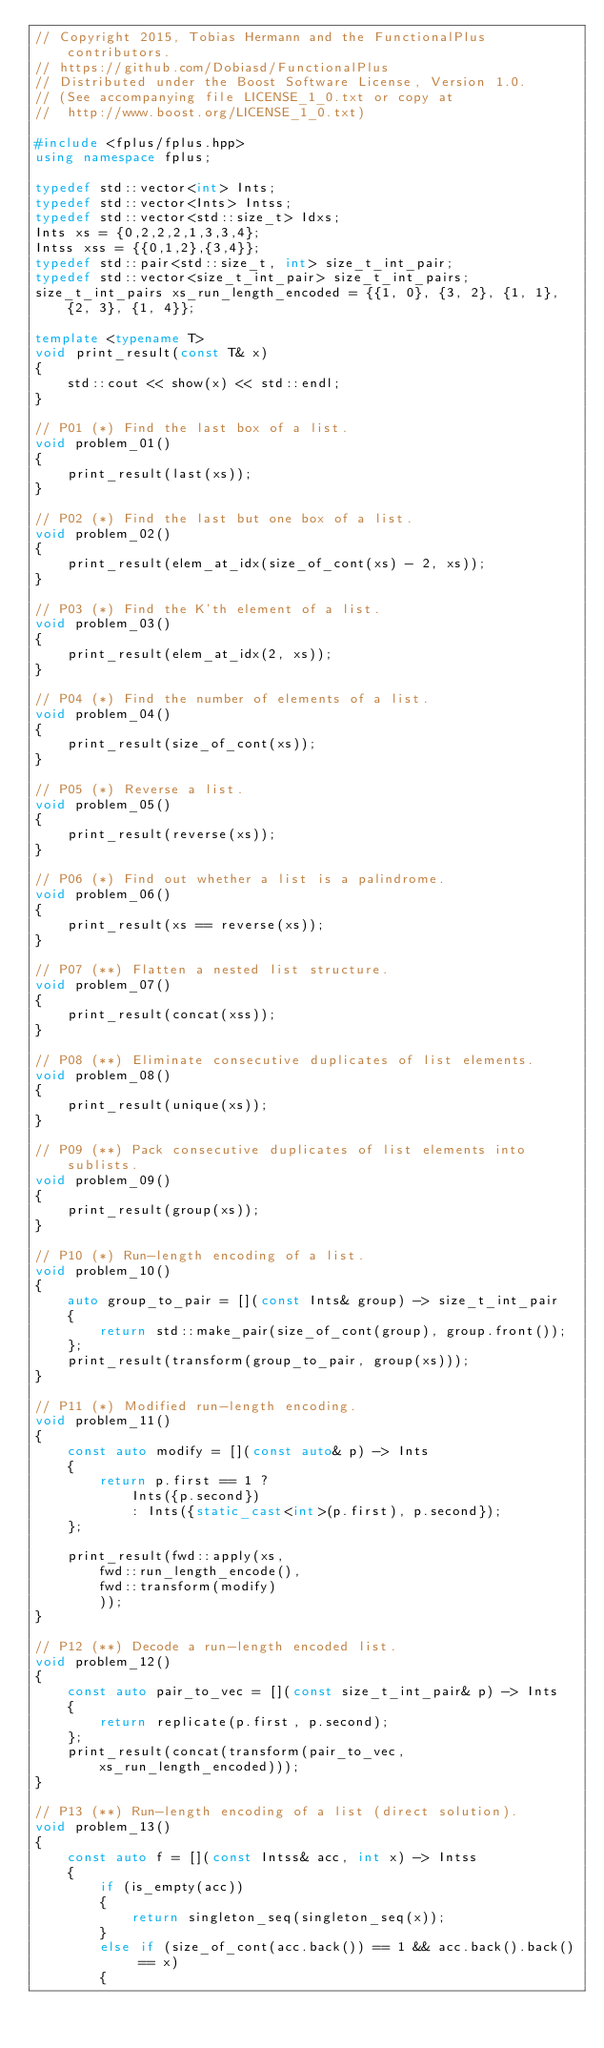<code> <loc_0><loc_0><loc_500><loc_500><_C++_>// Copyright 2015, Tobias Hermann and the FunctionalPlus contributors.
// https://github.com/Dobiasd/FunctionalPlus
// Distributed under the Boost Software License, Version 1.0.
// (See accompanying file LICENSE_1_0.txt or copy at
//  http://www.boost.org/LICENSE_1_0.txt)

#include <fplus/fplus.hpp>
using namespace fplus;

typedef std::vector<int> Ints;
typedef std::vector<Ints> Intss;
typedef std::vector<std::size_t> Idxs;
Ints xs = {0,2,2,2,1,3,3,4};
Intss xss = {{0,1,2},{3,4}};
typedef std::pair<std::size_t, int> size_t_int_pair;
typedef std::vector<size_t_int_pair> size_t_int_pairs;
size_t_int_pairs xs_run_length_encoded = {{1, 0}, {3, 2}, {1, 1}, {2, 3}, {1, 4}};

template <typename T>
void print_result(const T& x)
{
    std::cout << show(x) << std::endl;
}

// P01 (*) Find the last box of a list.
void problem_01()
{
    print_result(last(xs));
}

// P02 (*) Find the last but one box of a list.
void problem_02()
{
    print_result(elem_at_idx(size_of_cont(xs) - 2, xs));
}

// P03 (*) Find the K'th element of a list.
void problem_03()
{
    print_result(elem_at_idx(2, xs));
}

// P04 (*) Find the number of elements of a list.
void problem_04()
{
    print_result(size_of_cont(xs));
}

// P05 (*) Reverse a list.
void problem_05()
{
    print_result(reverse(xs));
}

// P06 (*) Find out whether a list is a palindrome.
void problem_06()
{
    print_result(xs == reverse(xs));
}

// P07 (**) Flatten a nested list structure.
void problem_07()
{
    print_result(concat(xss));
}

// P08 (**) Eliminate consecutive duplicates of list elements.
void problem_08()
{
    print_result(unique(xs));
}

// P09 (**) Pack consecutive duplicates of list elements into sublists.
void problem_09()
{
    print_result(group(xs));
}

// P10 (*) Run-length encoding of a list.
void problem_10()
{
    auto group_to_pair = [](const Ints& group) -> size_t_int_pair
    {
        return std::make_pair(size_of_cont(group), group.front());
    };
    print_result(transform(group_to_pair, group(xs)));
}

// P11 (*) Modified run-length encoding.
void problem_11()
{
    const auto modify = [](const auto& p) -> Ints
    {
        return p.first == 1 ?
            Ints({p.second})
            : Ints({static_cast<int>(p.first), p.second});
    };

    print_result(fwd::apply(xs,
        fwd::run_length_encode(),
        fwd::transform(modify)
        ));
}

// P12 (**) Decode a run-length encoded list.
void problem_12()
{
    const auto pair_to_vec = [](const size_t_int_pair& p) -> Ints
    {
        return replicate(p.first, p.second);
    };
    print_result(concat(transform(pair_to_vec, xs_run_length_encoded)));
}

// P13 (**) Run-length encoding of a list (direct solution).
void problem_13()
{
    const auto f = [](const Intss& acc, int x) -> Intss
    {
        if (is_empty(acc))
        {
            return singleton_seq(singleton_seq(x));
        }
        else if (size_of_cont(acc.back()) == 1 && acc.back().back() == x)
        {</code> 